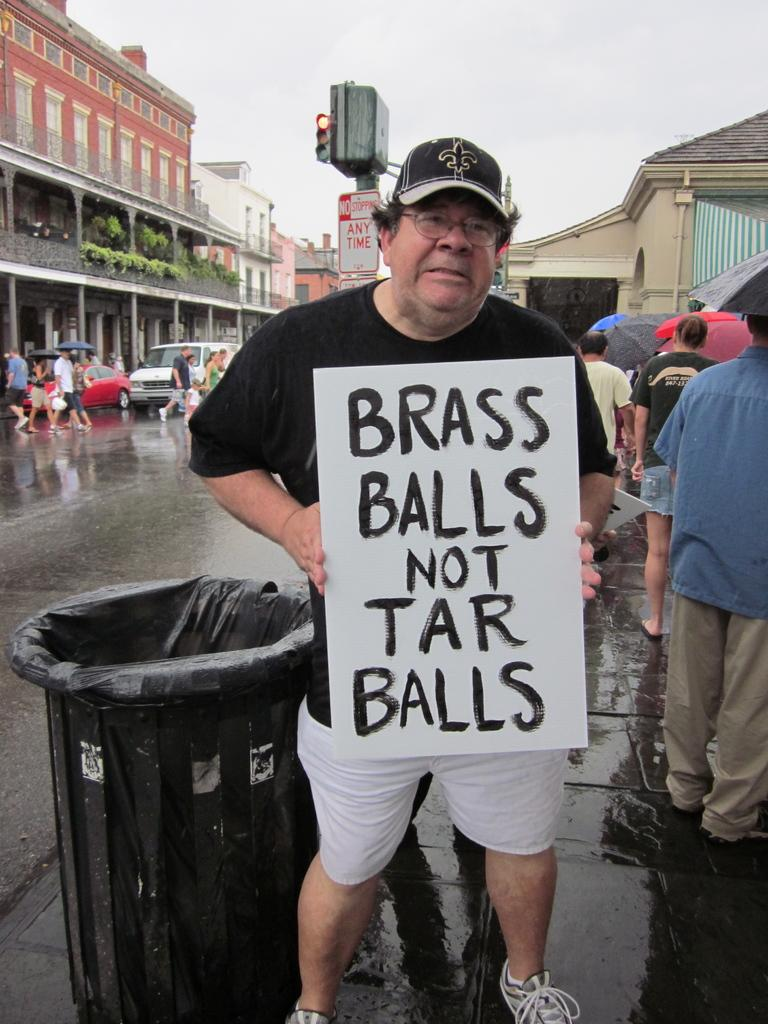<image>
Describe the image concisely. A man on the side of the street is holding a sign that says brass balls not tar balls. 